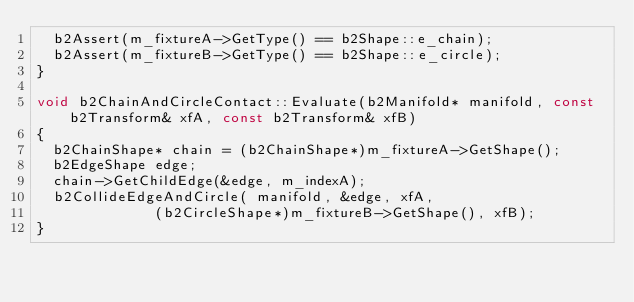<code> <loc_0><loc_0><loc_500><loc_500><_C++_>	b2Assert(m_fixtureA->GetType() == b2Shape::e_chain);
	b2Assert(m_fixtureB->GetType() == b2Shape::e_circle);
}

void b2ChainAndCircleContact::Evaluate(b2Manifold* manifold, const b2Transform& xfA, const b2Transform& xfB)
{
	b2ChainShape* chain = (b2ChainShape*)m_fixtureA->GetShape();
	b2EdgeShape edge;
	chain->GetChildEdge(&edge, m_indexA);
	b2CollideEdgeAndCircle(	manifold, &edge, xfA,
							(b2CircleShape*)m_fixtureB->GetShape(), xfB);
}
</code> 